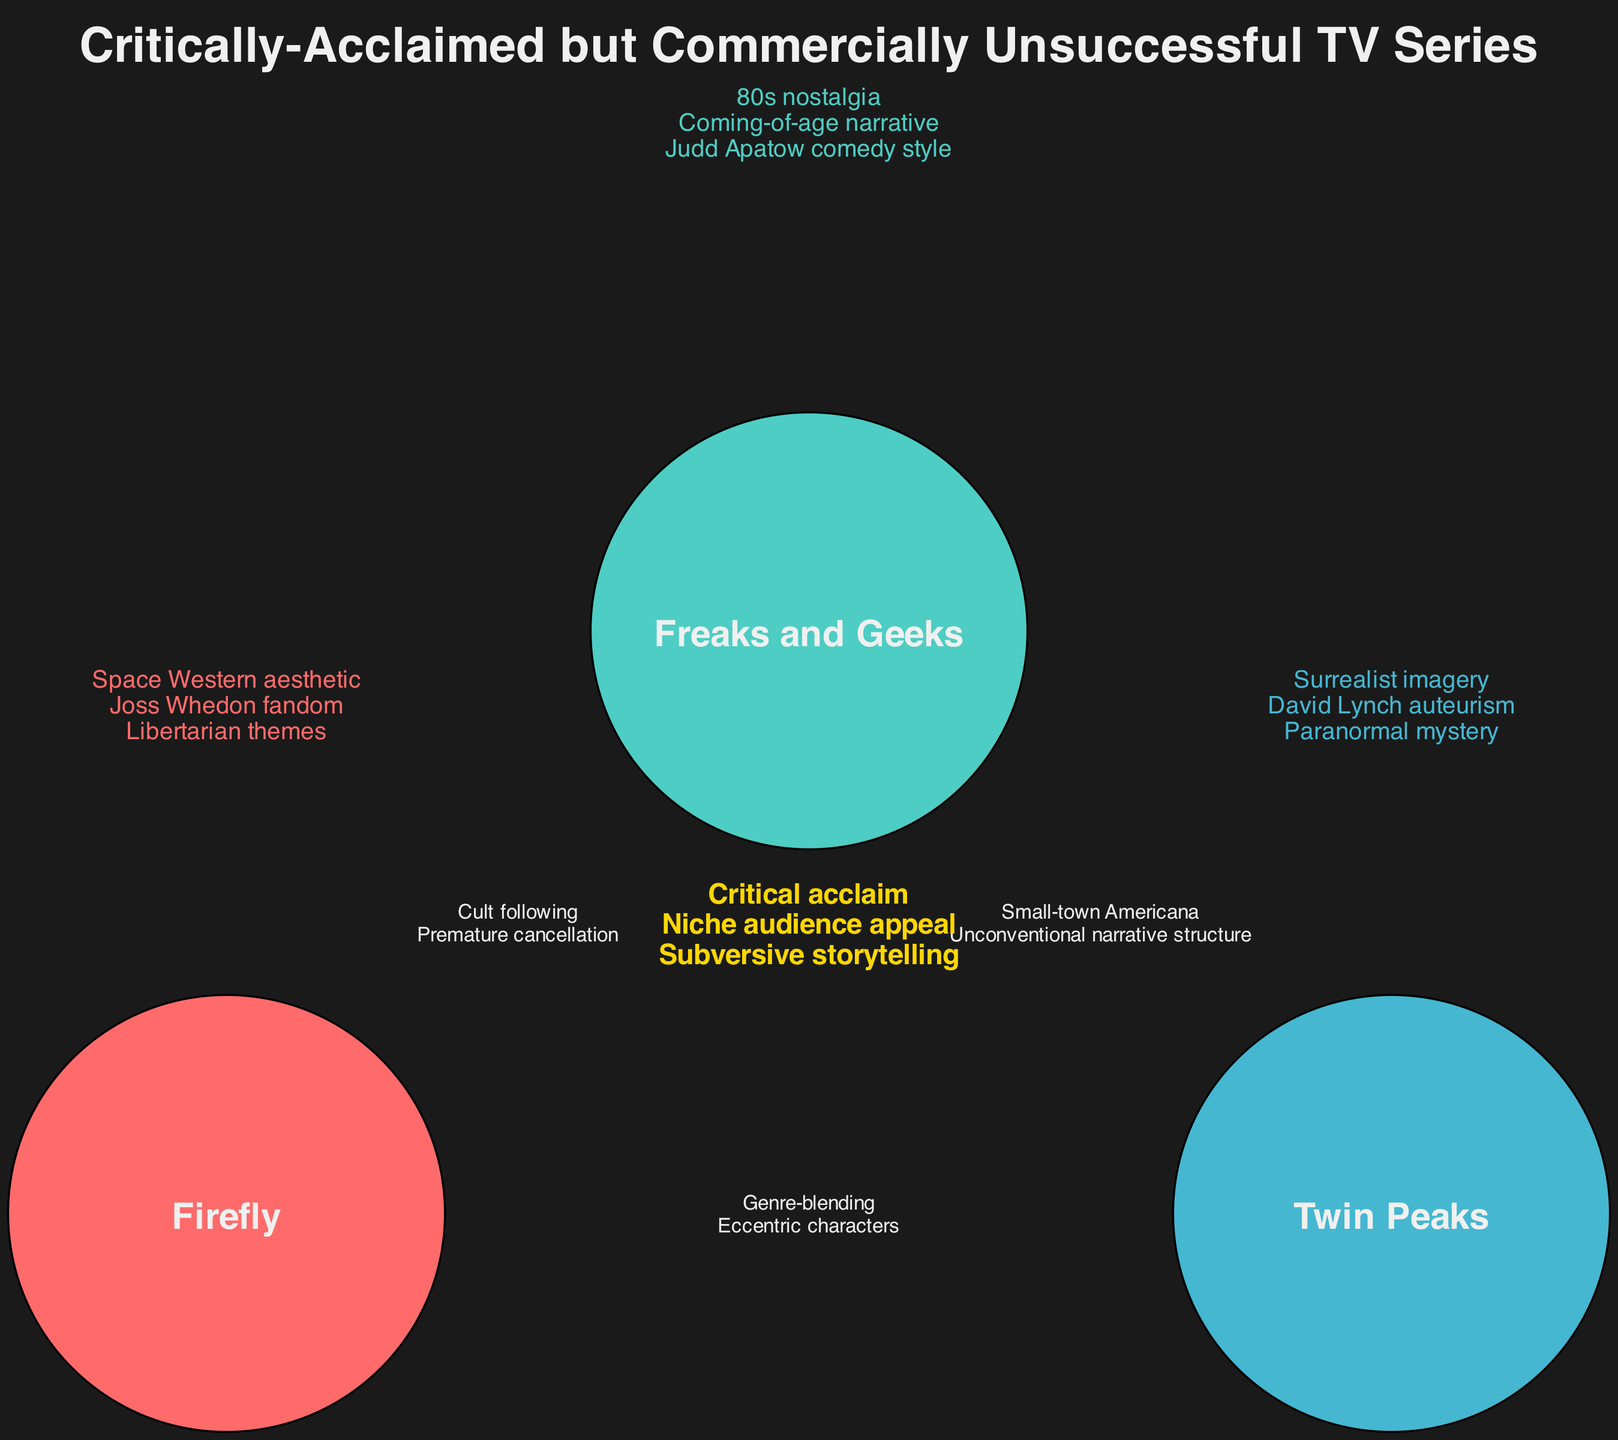What unique theme is associated with Firefly? The unique element "Libertarian themes" is specifically assigned to the set of "Firefly." Therefore, by directly looking at the unique elements listed under "Firefly," we can identify this theme.
Answer: Libertarian themes Which show features a coming-of-age narrative? In the unique elements under "Freaks and Geeks," the term "Coming-of-age narrative" directly indicates that this theme is associated with this show.
Answer: Coming-of-age narrative How many unique elements does Twin Peaks have? The unique elements listed for "Twin Peaks" are three: "Surrealist imagery," "David Lynch auteurism," and "Paranormal mystery." Counting these gives us the total number of unique elements for Twin Peaks.
Answer: 3 What common element do Firefly and Freaks and Geeks share? According to the intersections section, both "Firefly" and "Freaks and Geeks" share the elements "Cult following" and "Premature cancellation." Any of these would be a valid common element.
Answer: Cult following Which two shows share a theme related to small-town Americana? The intersection that includes "Freaks and Geeks" and "Twin Peaks" specifically lists "Small-town Americana" as a shared theme, making these the two shows in question.
Answer: Freaks and Geeks, Twin Peaks Which shows have eccentric characters in common? The intersection between "Firefly" and "Twin Peaks" includes the element "Eccentric characters," directly connecting these two shows regarding this theme.
Answer: Firefly, Twin Peaks What is the total number of intersections represented in the diagram? The intersections section lists four distinct intersections: two between pairs and one involving all three shows. Thus, counting these intersections gives a total of four.
Answer: 4 Which color represents Freaks and Geeks in the diagram? The diagram coding assigns specific colors to each show, with "Freaks and Geeks" represented by the second color, which is turquoise.
Answer: Turquoise Which three shows share a niche audience appeal according to the diagram? The common intersection involving all three shows indicates they all share the elements "Critical acclaim," "Niche audience appeal," and "Subversive storytelling." Therefore, all three shows are represented here.
Answer: Firefly, Freaks and Geeks, Twin Peaks 